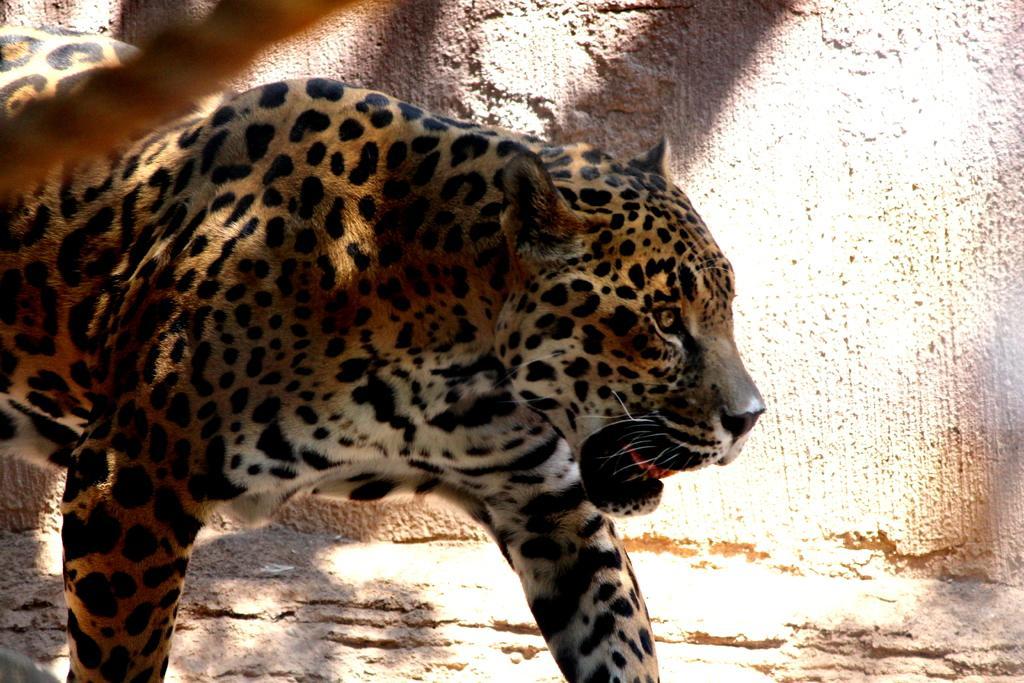Please provide a concise description of this image. This picture seems to be clicked outside. In the foreground there is an animal seems to be a leopard standing on the ground. In the background we can see the wall. 